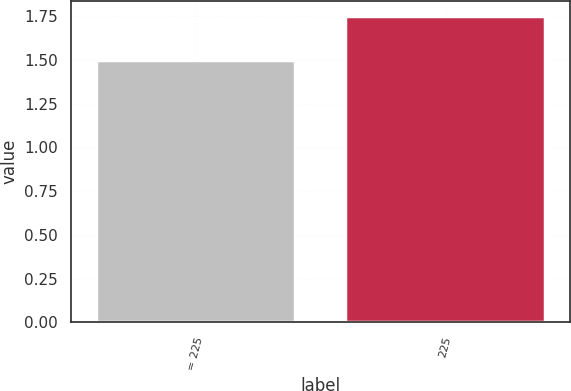<chart> <loc_0><loc_0><loc_500><loc_500><bar_chart><fcel>= 225<fcel>225<nl><fcel>1.5<fcel>1.75<nl></chart> 